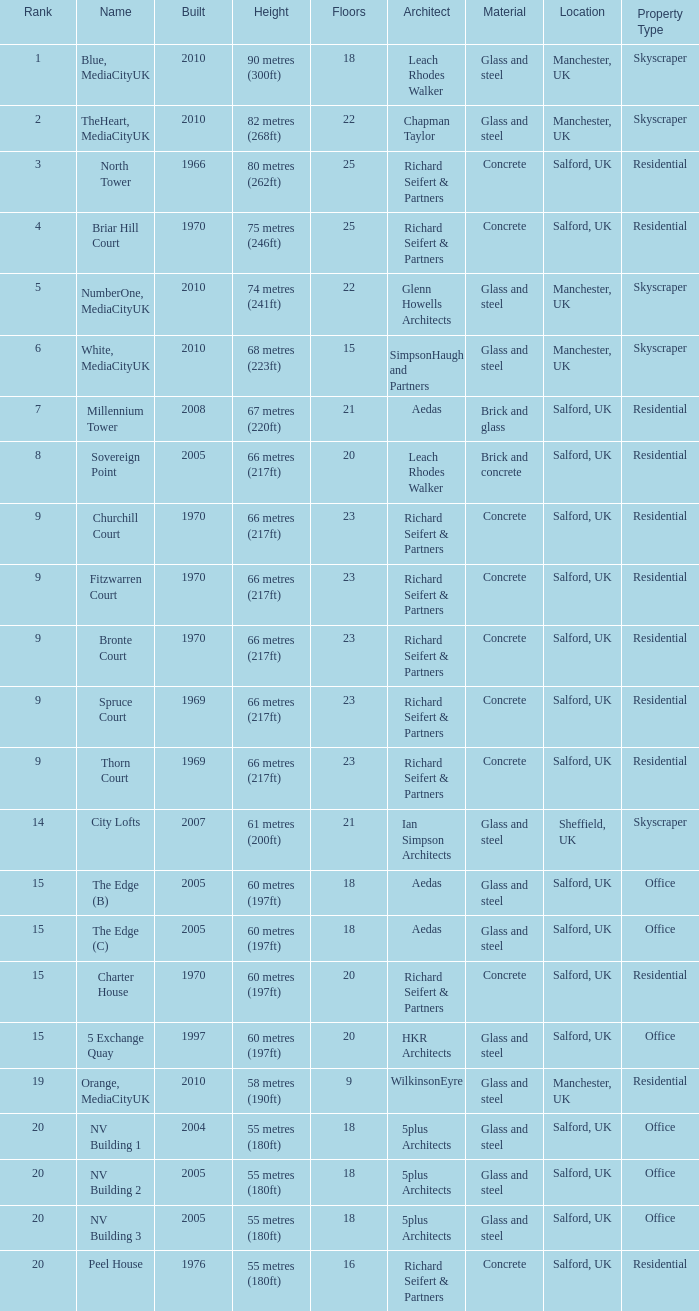What is the lowest Floors, when Built is greater than 1970, and when Name is NV Building 3? 18.0. 